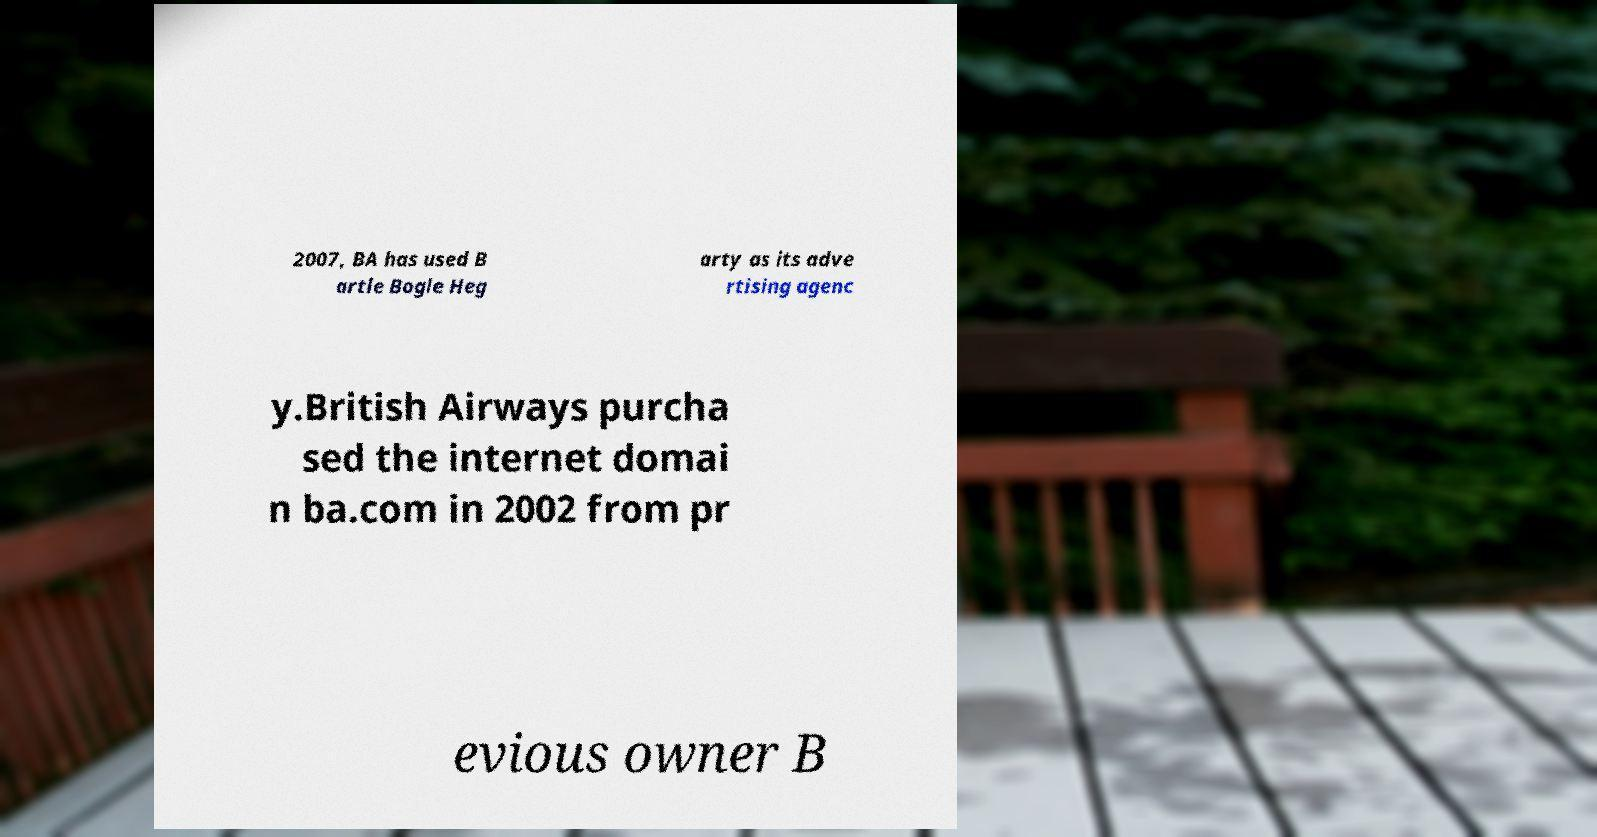For documentation purposes, I need the text within this image transcribed. Could you provide that? 2007, BA has used B artle Bogle Heg arty as its adve rtising agenc y.British Airways purcha sed the internet domai n ba.com in 2002 from pr evious owner B 